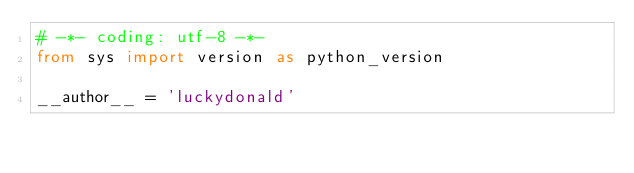Convert code to text. <code><loc_0><loc_0><loc_500><loc_500><_Python_># -*- coding: utf-8 -*-
from sys import version as python_version

__author__ = 'luckydonald'</code> 